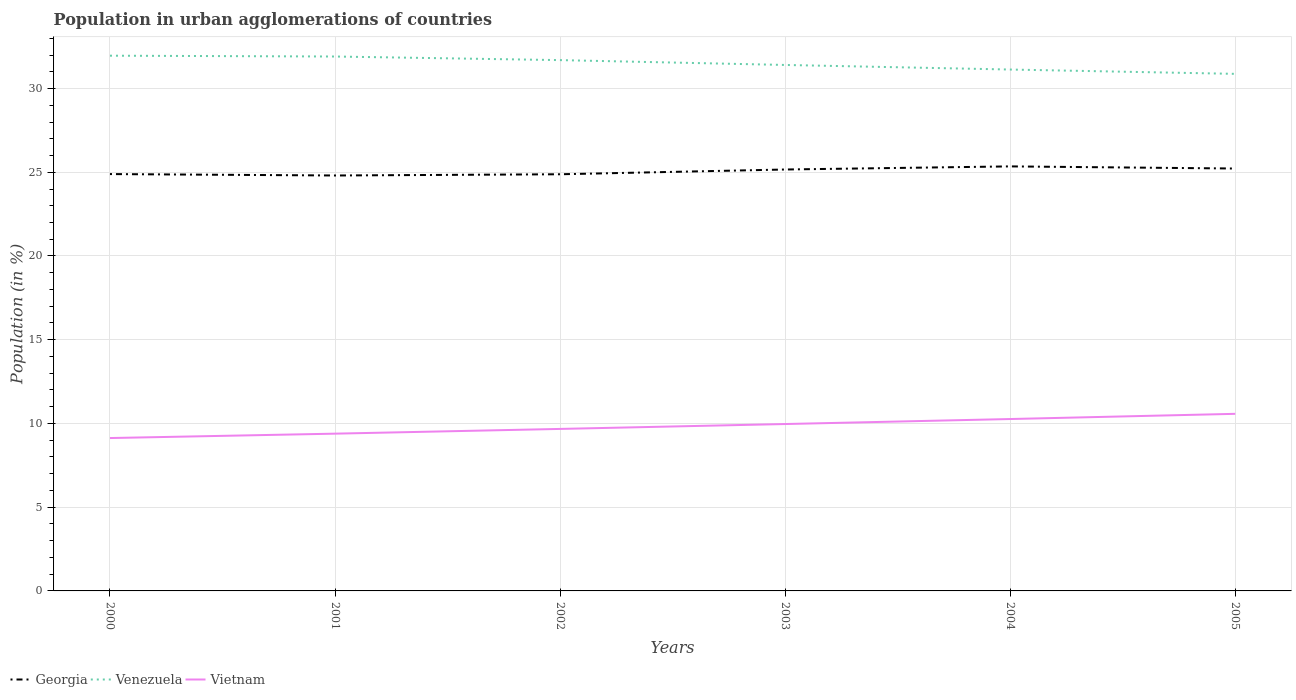How many different coloured lines are there?
Give a very brief answer. 3. Is the number of lines equal to the number of legend labels?
Your answer should be very brief. Yes. Across all years, what is the maximum percentage of population in urban agglomerations in Venezuela?
Ensure brevity in your answer.  30.88. What is the total percentage of population in urban agglomerations in Georgia in the graph?
Provide a short and direct response. -0.36. What is the difference between the highest and the second highest percentage of population in urban agglomerations in Venezuela?
Keep it short and to the point. 1.08. Is the percentage of population in urban agglomerations in Georgia strictly greater than the percentage of population in urban agglomerations in Vietnam over the years?
Your answer should be compact. No. How many years are there in the graph?
Your answer should be very brief. 6. Where does the legend appear in the graph?
Keep it short and to the point. Bottom left. How are the legend labels stacked?
Provide a succinct answer. Horizontal. What is the title of the graph?
Offer a terse response. Population in urban agglomerations of countries. Does "High income" appear as one of the legend labels in the graph?
Provide a succinct answer. No. What is the label or title of the X-axis?
Your answer should be very brief. Years. What is the Population (in %) of Georgia in 2000?
Ensure brevity in your answer.  24.89. What is the Population (in %) of Venezuela in 2000?
Your answer should be very brief. 31.96. What is the Population (in %) in Vietnam in 2000?
Your answer should be compact. 9.13. What is the Population (in %) in Georgia in 2001?
Offer a very short reply. 24.81. What is the Population (in %) of Venezuela in 2001?
Provide a short and direct response. 31.91. What is the Population (in %) in Vietnam in 2001?
Your answer should be compact. 9.39. What is the Population (in %) of Georgia in 2002?
Offer a very short reply. 24.88. What is the Population (in %) in Venezuela in 2002?
Provide a succinct answer. 31.7. What is the Population (in %) in Vietnam in 2002?
Give a very brief answer. 9.67. What is the Population (in %) in Georgia in 2003?
Keep it short and to the point. 25.16. What is the Population (in %) in Venezuela in 2003?
Provide a succinct answer. 31.41. What is the Population (in %) in Vietnam in 2003?
Give a very brief answer. 9.97. What is the Population (in %) of Georgia in 2004?
Make the answer very short. 25.35. What is the Population (in %) of Venezuela in 2004?
Provide a succinct answer. 31.13. What is the Population (in %) of Vietnam in 2004?
Offer a very short reply. 10.26. What is the Population (in %) in Georgia in 2005?
Offer a very short reply. 25.22. What is the Population (in %) of Venezuela in 2005?
Your answer should be compact. 30.88. What is the Population (in %) of Vietnam in 2005?
Provide a succinct answer. 10.57. Across all years, what is the maximum Population (in %) of Georgia?
Offer a very short reply. 25.35. Across all years, what is the maximum Population (in %) in Venezuela?
Offer a very short reply. 31.96. Across all years, what is the maximum Population (in %) in Vietnam?
Offer a terse response. 10.57. Across all years, what is the minimum Population (in %) of Georgia?
Ensure brevity in your answer.  24.81. Across all years, what is the minimum Population (in %) of Venezuela?
Ensure brevity in your answer.  30.88. Across all years, what is the minimum Population (in %) of Vietnam?
Make the answer very short. 9.13. What is the total Population (in %) in Georgia in the graph?
Provide a short and direct response. 150.32. What is the total Population (in %) in Venezuela in the graph?
Provide a short and direct response. 188.98. What is the total Population (in %) of Vietnam in the graph?
Ensure brevity in your answer.  59. What is the difference between the Population (in %) in Georgia in 2000 and that in 2001?
Your answer should be very brief. 0.09. What is the difference between the Population (in %) of Venezuela in 2000 and that in 2001?
Make the answer very short. 0.05. What is the difference between the Population (in %) of Vietnam in 2000 and that in 2001?
Provide a short and direct response. -0.26. What is the difference between the Population (in %) in Georgia in 2000 and that in 2002?
Give a very brief answer. 0.01. What is the difference between the Population (in %) in Venezuela in 2000 and that in 2002?
Your response must be concise. 0.26. What is the difference between the Population (in %) of Vietnam in 2000 and that in 2002?
Provide a succinct answer. -0.55. What is the difference between the Population (in %) in Georgia in 2000 and that in 2003?
Offer a terse response. -0.27. What is the difference between the Population (in %) of Venezuela in 2000 and that in 2003?
Offer a terse response. 0.55. What is the difference between the Population (in %) of Vietnam in 2000 and that in 2003?
Provide a short and direct response. -0.84. What is the difference between the Population (in %) of Georgia in 2000 and that in 2004?
Provide a short and direct response. -0.46. What is the difference between the Population (in %) in Venezuela in 2000 and that in 2004?
Offer a terse response. 0.83. What is the difference between the Population (in %) of Vietnam in 2000 and that in 2004?
Provide a short and direct response. -1.14. What is the difference between the Population (in %) of Georgia in 2000 and that in 2005?
Ensure brevity in your answer.  -0.33. What is the difference between the Population (in %) in Venezuela in 2000 and that in 2005?
Provide a short and direct response. 1.08. What is the difference between the Population (in %) of Vietnam in 2000 and that in 2005?
Your answer should be very brief. -1.45. What is the difference between the Population (in %) of Georgia in 2001 and that in 2002?
Your answer should be very brief. -0.07. What is the difference between the Population (in %) of Venezuela in 2001 and that in 2002?
Your answer should be compact. 0.21. What is the difference between the Population (in %) in Vietnam in 2001 and that in 2002?
Your answer should be very brief. -0.28. What is the difference between the Population (in %) in Georgia in 2001 and that in 2003?
Provide a succinct answer. -0.36. What is the difference between the Population (in %) of Venezuela in 2001 and that in 2003?
Your response must be concise. 0.5. What is the difference between the Population (in %) of Vietnam in 2001 and that in 2003?
Provide a short and direct response. -0.57. What is the difference between the Population (in %) in Georgia in 2001 and that in 2004?
Your answer should be very brief. -0.54. What is the difference between the Population (in %) in Venezuela in 2001 and that in 2004?
Your response must be concise. 0.78. What is the difference between the Population (in %) in Vietnam in 2001 and that in 2004?
Give a very brief answer. -0.87. What is the difference between the Population (in %) in Georgia in 2001 and that in 2005?
Give a very brief answer. -0.42. What is the difference between the Population (in %) in Venezuela in 2001 and that in 2005?
Ensure brevity in your answer.  1.04. What is the difference between the Population (in %) of Vietnam in 2001 and that in 2005?
Your response must be concise. -1.18. What is the difference between the Population (in %) in Georgia in 2002 and that in 2003?
Offer a very short reply. -0.28. What is the difference between the Population (in %) in Venezuela in 2002 and that in 2003?
Your answer should be very brief. 0.29. What is the difference between the Population (in %) in Vietnam in 2002 and that in 2003?
Provide a short and direct response. -0.29. What is the difference between the Population (in %) in Georgia in 2002 and that in 2004?
Your response must be concise. -0.47. What is the difference between the Population (in %) of Venezuela in 2002 and that in 2004?
Give a very brief answer. 0.56. What is the difference between the Population (in %) of Vietnam in 2002 and that in 2004?
Ensure brevity in your answer.  -0.59. What is the difference between the Population (in %) in Georgia in 2002 and that in 2005?
Keep it short and to the point. -0.34. What is the difference between the Population (in %) of Venezuela in 2002 and that in 2005?
Your response must be concise. 0.82. What is the difference between the Population (in %) in Vietnam in 2002 and that in 2005?
Your response must be concise. -0.9. What is the difference between the Population (in %) in Georgia in 2003 and that in 2004?
Make the answer very short. -0.19. What is the difference between the Population (in %) in Venezuela in 2003 and that in 2004?
Keep it short and to the point. 0.27. What is the difference between the Population (in %) in Vietnam in 2003 and that in 2004?
Your response must be concise. -0.3. What is the difference between the Population (in %) in Georgia in 2003 and that in 2005?
Ensure brevity in your answer.  -0.06. What is the difference between the Population (in %) of Venezuela in 2003 and that in 2005?
Your answer should be compact. 0.53. What is the difference between the Population (in %) of Vietnam in 2003 and that in 2005?
Provide a short and direct response. -0.61. What is the difference between the Population (in %) in Georgia in 2004 and that in 2005?
Make the answer very short. 0.13. What is the difference between the Population (in %) of Venezuela in 2004 and that in 2005?
Your response must be concise. 0.26. What is the difference between the Population (in %) of Vietnam in 2004 and that in 2005?
Keep it short and to the point. -0.31. What is the difference between the Population (in %) of Georgia in 2000 and the Population (in %) of Venezuela in 2001?
Provide a short and direct response. -7.02. What is the difference between the Population (in %) of Georgia in 2000 and the Population (in %) of Vietnam in 2001?
Keep it short and to the point. 15.5. What is the difference between the Population (in %) of Venezuela in 2000 and the Population (in %) of Vietnam in 2001?
Offer a very short reply. 22.57. What is the difference between the Population (in %) of Georgia in 2000 and the Population (in %) of Venezuela in 2002?
Offer a very short reply. -6.8. What is the difference between the Population (in %) of Georgia in 2000 and the Population (in %) of Vietnam in 2002?
Provide a short and direct response. 15.22. What is the difference between the Population (in %) of Venezuela in 2000 and the Population (in %) of Vietnam in 2002?
Offer a very short reply. 22.29. What is the difference between the Population (in %) of Georgia in 2000 and the Population (in %) of Venezuela in 2003?
Ensure brevity in your answer.  -6.52. What is the difference between the Population (in %) of Georgia in 2000 and the Population (in %) of Vietnam in 2003?
Make the answer very short. 14.93. What is the difference between the Population (in %) in Venezuela in 2000 and the Population (in %) in Vietnam in 2003?
Your response must be concise. 22. What is the difference between the Population (in %) of Georgia in 2000 and the Population (in %) of Venezuela in 2004?
Your answer should be very brief. -6.24. What is the difference between the Population (in %) in Georgia in 2000 and the Population (in %) in Vietnam in 2004?
Offer a terse response. 14.63. What is the difference between the Population (in %) of Venezuela in 2000 and the Population (in %) of Vietnam in 2004?
Keep it short and to the point. 21.7. What is the difference between the Population (in %) in Georgia in 2000 and the Population (in %) in Venezuela in 2005?
Give a very brief answer. -5.98. What is the difference between the Population (in %) of Georgia in 2000 and the Population (in %) of Vietnam in 2005?
Keep it short and to the point. 14.32. What is the difference between the Population (in %) in Venezuela in 2000 and the Population (in %) in Vietnam in 2005?
Make the answer very short. 21.39. What is the difference between the Population (in %) of Georgia in 2001 and the Population (in %) of Venezuela in 2002?
Provide a short and direct response. -6.89. What is the difference between the Population (in %) of Georgia in 2001 and the Population (in %) of Vietnam in 2002?
Offer a very short reply. 15.13. What is the difference between the Population (in %) of Venezuela in 2001 and the Population (in %) of Vietnam in 2002?
Offer a terse response. 22.24. What is the difference between the Population (in %) of Georgia in 2001 and the Population (in %) of Venezuela in 2003?
Offer a terse response. -6.6. What is the difference between the Population (in %) of Georgia in 2001 and the Population (in %) of Vietnam in 2003?
Your response must be concise. 14.84. What is the difference between the Population (in %) of Venezuela in 2001 and the Population (in %) of Vietnam in 2003?
Offer a very short reply. 21.95. What is the difference between the Population (in %) in Georgia in 2001 and the Population (in %) in Venezuela in 2004?
Make the answer very short. -6.33. What is the difference between the Population (in %) of Georgia in 2001 and the Population (in %) of Vietnam in 2004?
Provide a short and direct response. 14.54. What is the difference between the Population (in %) of Venezuela in 2001 and the Population (in %) of Vietnam in 2004?
Your answer should be compact. 21.65. What is the difference between the Population (in %) in Georgia in 2001 and the Population (in %) in Venezuela in 2005?
Make the answer very short. -6.07. What is the difference between the Population (in %) of Georgia in 2001 and the Population (in %) of Vietnam in 2005?
Provide a short and direct response. 14.23. What is the difference between the Population (in %) in Venezuela in 2001 and the Population (in %) in Vietnam in 2005?
Your response must be concise. 21.34. What is the difference between the Population (in %) of Georgia in 2002 and the Population (in %) of Venezuela in 2003?
Give a very brief answer. -6.53. What is the difference between the Population (in %) of Georgia in 2002 and the Population (in %) of Vietnam in 2003?
Keep it short and to the point. 14.91. What is the difference between the Population (in %) of Venezuela in 2002 and the Population (in %) of Vietnam in 2003?
Offer a very short reply. 21.73. What is the difference between the Population (in %) of Georgia in 2002 and the Population (in %) of Venezuela in 2004?
Your answer should be compact. -6.25. What is the difference between the Population (in %) of Georgia in 2002 and the Population (in %) of Vietnam in 2004?
Make the answer very short. 14.62. What is the difference between the Population (in %) of Venezuela in 2002 and the Population (in %) of Vietnam in 2004?
Ensure brevity in your answer.  21.43. What is the difference between the Population (in %) in Georgia in 2002 and the Population (in %) in Venezuela in 2005?
Provide a short and direct response. -6. What is the difference between the Population (in %) of Georgia in 2002 and the Population (in %) of Vietnam in 2005?
Offer a terse response. 14.31. What is the difference between the Population (in %) in Venezuela in 2002 and the Population (in %) in Vietnam in 2005?
Offer a terse response. 21.12. What is the difference between the Population (in %) in Georgia in 2003 and the Population (in %) in Venezuela in 2004?
Your answer should be very brief. -5.97. What is the difference between the Population (in %) of Georgia in 2003 and the Population (in %) of Vietnam in 2004?
Your answer should be very brief. 14.9. What is the difference between the Population (in %) of Venezuela in 2003 and the Population (in %) of Vietnam in 2004?
Your answer should be compact. 21.14. What is the difference between the Population (in %) of Georgia in 2003 and the Population (in %) of Venezuela in 2005?
Your answer should be very brief. -5.71. What is the difference between the Population (in %) of Georgia in 2003 and the Population (in %) of Vietnam in 2005?
Offer a very short reply. 14.59. What is the difference between the Population (in %) in Venezuela in 2003 and the Population (in %) in Vietnam in 2005?
Give a very brief answer. 20.83. What is the difference between the Population (in %) in Georgia in 2004 and the Population (in %) in Venezuela in 2005?
Give a very brief answer. -5.53. What is the difference between the Population (in %) in Georgia in 2004 and the Population (in %) in Vietnam in 2005?
Make the answer very short. 14.78. What is the difference between the Population (in %) of Venezuela in 2004 and the Population (in %) of Vietnam in 2005?
Offer a terse response. 20.56. What is the average Population (in %) of Georgia per year?
Keep it short and to the point. 25.05. What is the average Population (in %) of Venezuela per year?
Keep it short and to the point. 31.5. What is the average Population (in %) of Vietnam per year?
Offer a very short reply. 9.83. In the year 2000, what is the difference between the Population (in %) in Georgia and Population (in %) in Venezuela?
Offer a very short reply. -7.07. In the year 2000, what is the difference between the Population (in %) of Georgia and Population (in %) of Vietnam?
Your answer should be compact. 15.76. In the year 2000, what is the difference between the Population (in %) in Venezuela and Population (in %) in Vietnam?
Provide a short and direct response. 22.83. In the year 2001, what is the difference between the Population (in %) of Georgia and Population (in %) of Venezuela?
Provide a succinct answer. -7.1. In the year 2001, what is the difference between the Population (in %) of Georgia and Population (in %) of Vietnam?
Offer a terse response. 15.42. In the year 2001, what is the difference between the Population (in %) in Venezuela and Population (in %) in Vietnam?
Make the answer very short. 22.52. In the year 2002, what is the difference between the Population (in %) in Georgia and Population (in %) in Venezuela?
Ensure brevity in your answer.  -6.82. In the year 2002, what is the difference between the Population (in %) in Georgia and Population (in %) in Vietnam?
Provide a succinct answer. 15.21. In the year 2002, what is the difference between the Population (in %) in Venezuela and Population (in %) in Vietnam?
Your response must be concise. 22.02. In the year 2003, what is the difference between the Population (in %) of Georgia and Population (in %) of Venezuela?
Make the answer very short. -6.24. In the year 2003, what is the difference between the Population (in %) of Georgia and Population (in %) of Vietnam?
Offer a terse response. 15.2. In the year 2003, what is the difference between the Population (in %) of Venezuela and Population (in %) of Vietnam?
Your response must be concise. 21.44. In the year 2004, what is the difference between the Population (in %) in Georgia and Population (in %) in Venezuela?
Give a very brief answer. -5.78. In the year 2004, what is the difference between the Population (in %) of Georgia and Population (in %) of Vietnam?
Make the answer very short. 15.09. In the year 2004, what is the difference between the Population (in %) of Venezuela and Population (in %) of Vietnam?
Your answer should be very brief. 20.87. In the year 2005, what is the difference between the Population (in %) in Georgia and Population (in %) in Venezuela?
Your answer should be very brief. -5.65. In the year 2005, what is the difference between the Population (in %) of Georgia and Population (in %) of Vietnam?
Your answer should be very brief. 14.65. In the year 2005, what is the difference between the Population (in %) of Venezuela and Population (in %) of Vietnam?
Make the answer very short. 20.3. What is the ratio of the Population (in %) in Georgia in 2000 to that in 2001?
Make the answer very short. 1. What is the ratio of the Population (in %) in Venezuela in 2000 to that in 2001?
Make the answer very short. 1. What is the ratio of the Population (in %) of Vietnam in 2000 to that in 2001?
Provide a short and direct response. 0.97. What is the ratio of the Population (in %) of Georgia in 2000 to that in 2002?
Your response must be concise. 1. What is the ratio of the Population (in %) of Venezuela in 2000 to that in 2002?
Keep it short and to the point. 1.01. What is the ratio of the Population (in %) in Vietnam in 2000 to that in 2002?
Keep it short and to the point. 0.94. What is the ratio of the Population (in %) of Georgia in 2000 to that in 2003?
Give a very brief answer. 0.99. What is the ratio of the Population (in %) in Venezuela in 2000 to that in 2003?
Your answer should be very brief. 1.02. What is the ratio of the Population (in %) in Vietnam in 2000 to that in 2003?
Provide a short and direct response. 0.92. What is the ratio of the Population (in %) in Georgia in 2000 to that in 2004?
Provide a succinct answer. 0.98. What is the ratio of the Population (in %) in Venezuela in 2000 to that in 2004?
Keep it short and to the point. 1.03. What is the ratio of the Population (in %) in Vietnam in 2000 to that in 2004?
Make the answer very short. 0.89. What is the ratio of the Population (in %) of Georgia in 2000 to that in 2005?
Keep it short and to the point. 0.99. What is the ratio of the Population (in %) in Venezuela in 2000 to that in 2005?
Provide a short and direct response. 1.04. What is the ratio of the Population (in %) in Vietnam in 2000 to that in 2005?
Give a very brief answer. 0.86. What is the ratio of the Population (in %) of Georgia in 2001 to that in 2002?
Offer a very short reply. 1. What is the ratio of the Population (in %) in Venezuela in 2001 to that in 2002?
Provide a short and direct response. 1.01. What is the ratio of the Population (in %) in Vietnam in 2001 to that in 2002?
Your answer should be very brief. 0.97. What is the ratio of the Population (in %) of Georgia in 2001 to that in 2003?
Make the answer very short. 0.99. What is the ratio of the Population (in %) in Venezuela in 2001 to that in 2003?
Provide a succinct answer. 1.02. What is the ratio of the Population (in %) of Vietnam in 2001 to that in 2003?
Offer a terse response. 0.94. What is the ratio of the Population (in %) of Georgia in 2001 to that in 2004?
Provide a short and direct response. 0.98. What is the ratio of the Population (in %) of Vietnam in 2001 to that in 2004?
Provide a succinct answer. 0.92. What is the ratio of the Population (in %) in Georgia in 2001 to that in 2005?
Your answer should be compact. 0.98. What is the ratio of the Population (in %) in Venezuela in 2001 to that in 2005?
Your answer should be compact. 1.03. What is the ratio of the Population (in %) in Vietnam in 2001 to that in 2005?
Give a very brief answer. 0.89. What is the ratio of the Population (in %) of Georgia in 2002 to that in 2003?
Your answer should be compact. 0.99. What is the ratio of the Population (in %) in Venezuela in 2002 to that in 2003?
Ensure brevity in your answer.  1.01. What is the ratio of the Population (in %) of Vietnam in 2002 to that in 2003?
Your answer should be compact. 0.97. What is the ratio of the Population (in %) of Georgia in 2002 to that in 2004?
Give a very brief answer. 0.98. What is the ratio of the Population (in %) of Venezuela in 2002 to that in 2004?
Your answer should be very brief. 1.02. What is the ratio of the Population (in %) of Vietnam in 2002 to that in 2004?
Keep it short and to the point. 0.94. What is the ratio of the Population (in %) of Georgia in 2002 to that in 2005?
Provide a short and direct response. 0.99. What is the ratio of the Population (in %) of Venezuela in 2002 to that in 2005?
Ensure brevity in your answer.  1.03. What is the ratio of the Population (in %) in Vietnam in 2002 to that in 2005?
Offer a terse response. 0.91. What is the ratio of the Population (in %) in Venezuela in 2003 to that in 2004?
Your answer should be compact. 1.01. What is the ratio of the Population (in %) of Vietnam in 2003 to that in 2004?
Make the answer very short. 0.97. What is the ratio of the Population (in %) of Georgia in 2003 to that in 2005?
Your answer should be compact. 1. What is the ratio of the Population (in %) of Venezuela in 2003 to that in 2005?
Offer a very short reply. 1.02. What is the ratio of the Population (in %) in Vietnam in 2003 to that in 2005?
Offer a very short reply. 0.94. What is the ratio of the Population (in %) in Venezuela in 2004 to that in 2005?
Your answer should be compact. 1.01. What is the ratio of the Population (in %) of Vietnam in 2004 to that in 2005?
Ensure brevity in your answer.  0.97. What is the difference between the highest and the second highest Population (in %) of Georgia?
Provide a short and direct response. 0.13. What is the difference between the highest and the second highest Population (in %) of Venezuela?
Make the answer very short. 0.05. What is the difference between the highest and the second highest Population (in %) of Vietnam?
Provide a succinct answer. 0.31. What is the difference between the highest and the lowest Population (in %) in Georgia?
Make the answer very short. 0.54. What is the difference between the highest and the lowest Population (in %) of Venezuela?
Give a very brief answer. 1.08. What is the difference between the highest and the lowest Population (in %) of Vietnam?
Provide a succinct answer. 1.45. 